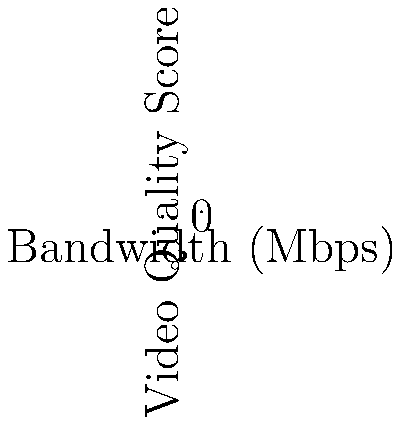Analyze the line graph showing the relationship between bandwidth and video quality for telehealth consultations using two different camera types. At what bandwidth does the difference in video quality between the high-resolution and standard cameras become negligible (less than 0.5 points)? How might this information influence decision-making in telehealth platform integration? To answer this question, we need to follow these steps:

1. Understand the graph:
   - The x-axis represents bandwidth in Mbps
   - The y-axis represents video quality score
   - Blue line with circles represents high-resolution camera
   - Red line with crosses represents standard camera

2. Calculate the difference in video quality at each bandwidth point:
   - At 1 Mbps: 2.0 - 1.5 = 0.5
   - At 2 Mbps: 3.5 - 2.8 = 0.7
   - At 3 Mbps: 4.5 - 3.8 = 0.7
   - At 4 Mbps: 5.0 - 4.5 = 0.5
   - At 5 Mbps: 5.3 - 4.9 = 0.4
   - At 6 Mbps: 5.5 - 5.2 = 0.3
   - At 7 Mbps: 5.6 - 5.4 = 0.2
   - At 8 Mbps: 5.7 - 5.5 = 0.2

3. Identify the point where the difference becomes less than 0.5:
   The difference becomes less than 0.5 at 5 Mbps (0.4 difference).

4. Implications for telehealth platform integration:
   - At bandwidths below 5 Mbps, high-resolution cameras provide noticeably better video quality.
   - Above 5 Mbps, the advantage of high-resolution cameras diminishes.
   - Healthcare facilities with limited bandwidth (< 5 Mbps) may benefit more from high-resolution cameras.
   - Facilities with bandwidth > 5 Mbps may not see significant improvements with high-resolution cameras.
   - This information can help in cost-benefit analysis when choosing between standard and high-resolution cameras for telehealth consultations.
   - It also highlights the importance of ensuring at least 5 Mbps bandwidth for optimal telehealth video quality, regardless of camera type.
Answer: 5 Mbps 